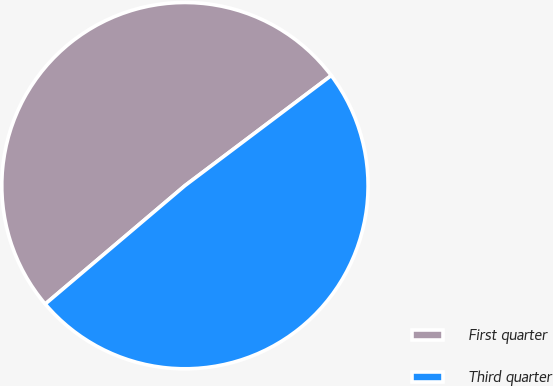<chart> <loc_0><loc_0><loc_500><loc_500><pie_chart><fcel>First quarter<fcel>Third quarter<nl><fcel>50.92%<fcel>49.08%<nl></chart> 